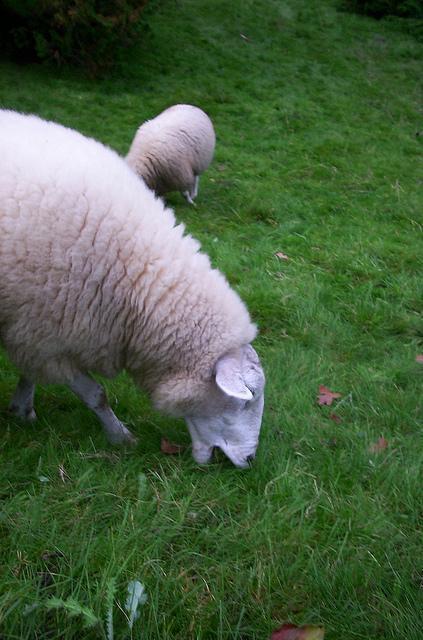How many sheep are in the photo?
Give a very brief answer. 2. 